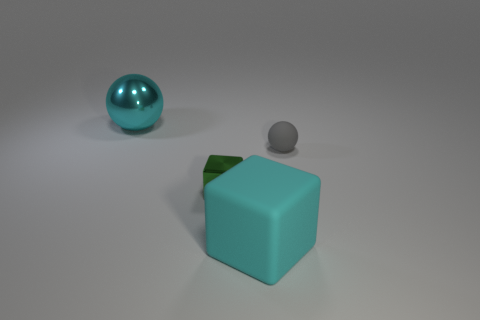Subtract all yellow blocks. Subtract all green cylinders. How many blocks are left? 2 Subtract all blue spheres. How many brown blocks are left? 0 Add 1 small grays. How many large cyans exist? 0 Subtract all gray things. Subtract all big cyan shiny things. How many objects are left? 2 Add 3 cyan rubber things. How many cyan rubber things are left? 4 Add 1 large blue rubber balls. How many large blue rubber balls exist? 1 Add 2 spheres. How many objects exist? 6 Subtract all cyan cubes. How many cubes are left? 1 Subtract 0 purple spheres. How many objects are left? 4 Subtract 1 cubes. How many cubes are left? 1 